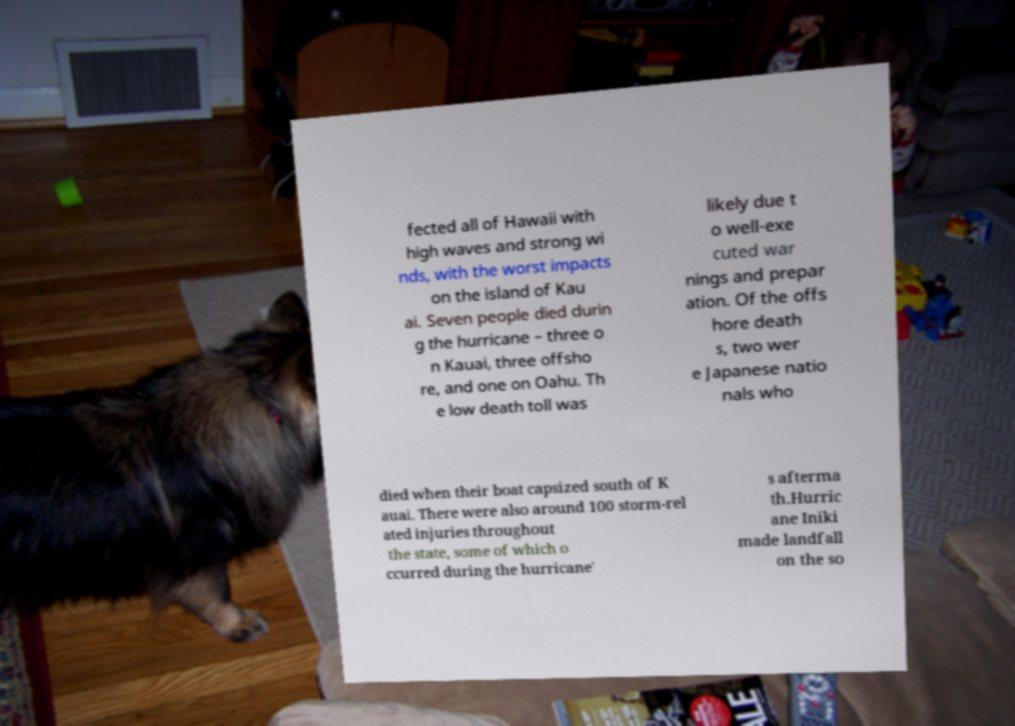What messages or text are displayed in this image? I need them in a readable, typed format. fected all of Hawaii with high waves and strong wi nds, with the worst impacts on the island of Kau ai. Seven people died durin g the hurricane – three o n Kauai, three offsho re, and one on Oahu. Th e low death toll was likely due t o well-exe cuted war nings and prepar ation. Of the offs hore death s, two wer e Japanese natio nals who died when their boat capsized south of K auai. There were also around 100 storm-rel ated injuries throughout the state, some of which o ccurred during the hurricane' s afterma th.Hurric ane Iniki made landfall on the so 